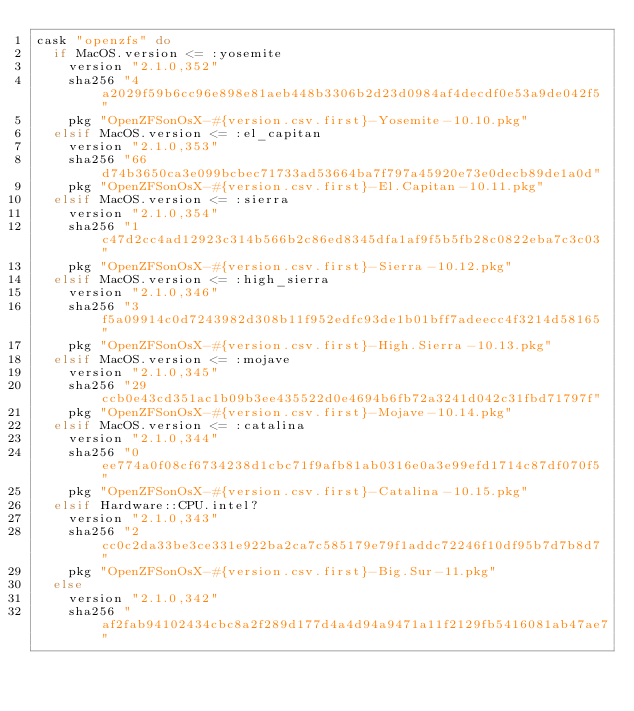<code> <loc_0><loc_0><loc_500><loc_500><_Ruby_>cask "openzfs" do
  if MacOS.version <= :yosemite
    version "2.1.0,352"
    sha256 "4a2029f59b6cc96e898e81aeb448b3306b2d23d0984af4decdf0e53a9de042f5"
    pkg "OpenZFSonOsX-#{version.csv.first}-Yosemite-10.10.pkg"
  elsif MacOS.version <= :el_capitan
    version "2.1.0,353"
    sha256 "66d74b3650ca3e099bcbec71733ad53664ba7f797a45920e73e0decb89de1a0d"
    pkg "OpenZFSonOsX-#{version.csv.first}-El.Capitan-10.11.pkg"
  elsif MacOS.version <= :sierra
    version "2.1.0,354"
    sha256 "1c47d2cc4ad12923c314b566b2c86ed8345dfa1af9f5b5fb28c0822eba7c3c03"
    pkg "OpenZFSonOsX-#{version.csv.first}-Sierra-10.12.pkg"
  elsif MacOS.version <= :high_sierra
    version "2.1.0,346"
    sha256 "3f5a09914c0d7243982d308b11f952edfc93de1b01bff7adeecc4f3214d58165"
    pkg "OpenZFSonOsX-#{version.csv.first}-High.Sierra-10.13.pkg"
  elsif MacOS.version <= :mojave
    version "2.1.0,345"
    sha256 "29ccb0e43cd351ac1b09b3ee435522d0e4694b6fb72a3241d042c31fbd71797f"
    pkg "OpenZFSonOsX-#{version.csv.first}-Mojave-10.14.pkg"
  elsif MacOS.version <= :catalina
    version "2.1.0,344"
    sha256 "0ee774a0f08cf6734238d1cbc71f9afb81ab0316e0a3e99efd1714c87df070f5"
    pkg "OpenZFSonOsX-#{version.csv.first}-Catalina-10.15.pkg"
  elsif Hardware::CPU.intel?
    version "2.1.0,343"
    sha256 "2cc0c2da33be3ce331e922ba2ca7c585179e79f1addc72246f10df95b7d7b8d7"
    pkg "OpenZFSonOsX-#{version.csv.first}-Big.Sur-11.pkg"
  else
    version "2.1.0,342"
    sha256 "af2fab94102434cbc8a2f289d177d4a4d94a9471a11f2129fb5416081ab47ae7"</code> 